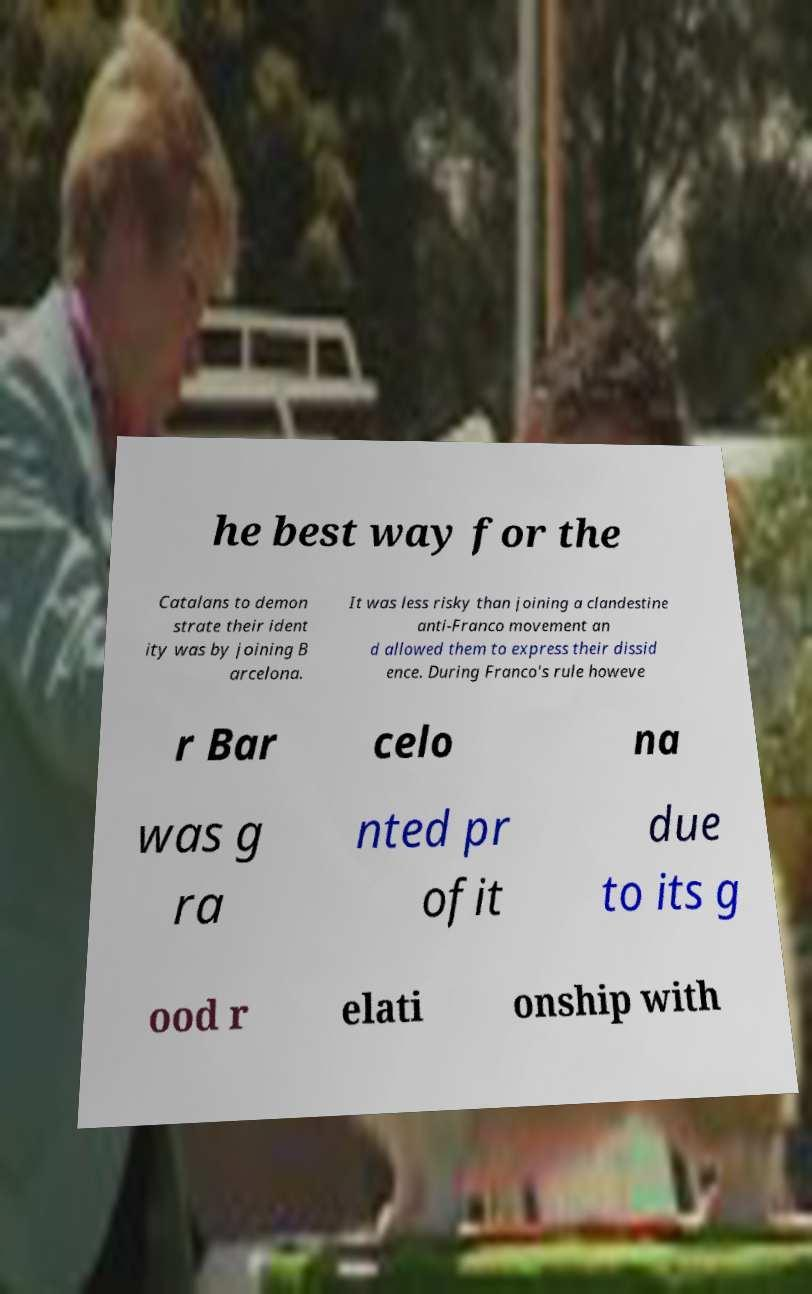Can you read and provide the text displayed in the image?This photo seems to have some interesting text. Can you extract and type it out for me? he best way for the Catalans to demon strate their ident ity was by joining B arcelona. It was less risky than joining a clandestine anti-Franco movement an d allowed them to express their dissid ence. During Franco's rule howeve r Bar celo na was g ra nted pr ofit due to its g ood r elati onship with 